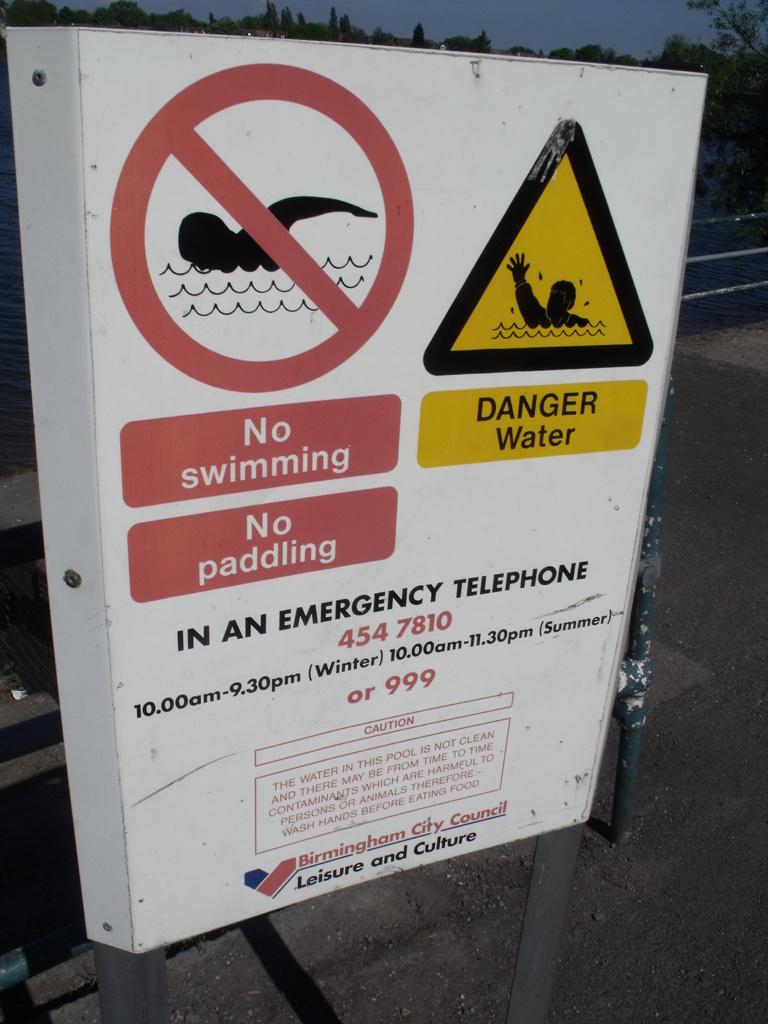What is their a danger of?
Keep it short and to the point. Water. 